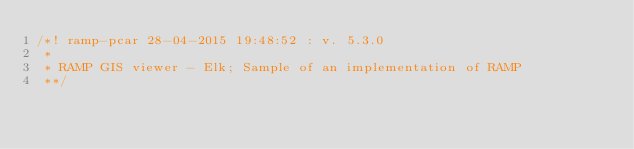<code> <loc_0><loc_0><loc_500><loc_500><_JavaScript_>/*! ramp-pcar 28-04-2015 19:48:52 : v. 5.3.0 
 * 
 * RAMP GIS viewer - Elk; Sample of an implementation of RAMP 
 **/</code> 